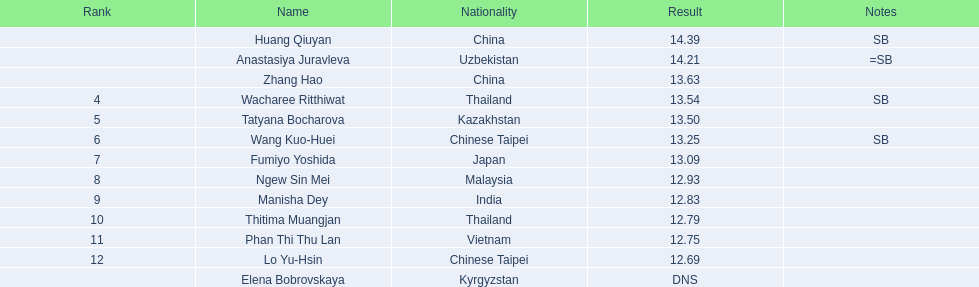How do the results of huang qiuyan and fumiyo yoshida differ? 1.3. 